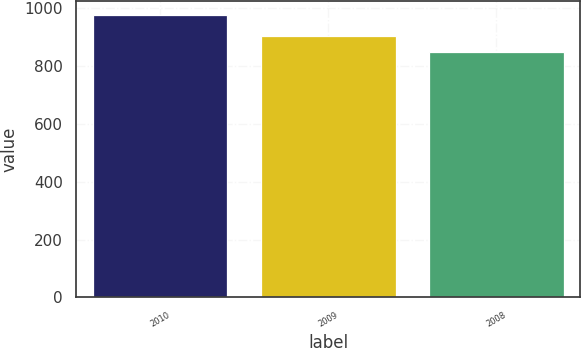<chart> <loc_0><loc_0><loc_500><loc_500><bar_chart><fcel>2010<fcel>2009<fcel>2008<nl><fcel>978<fcel>905<fcel>850<nl></chart> 